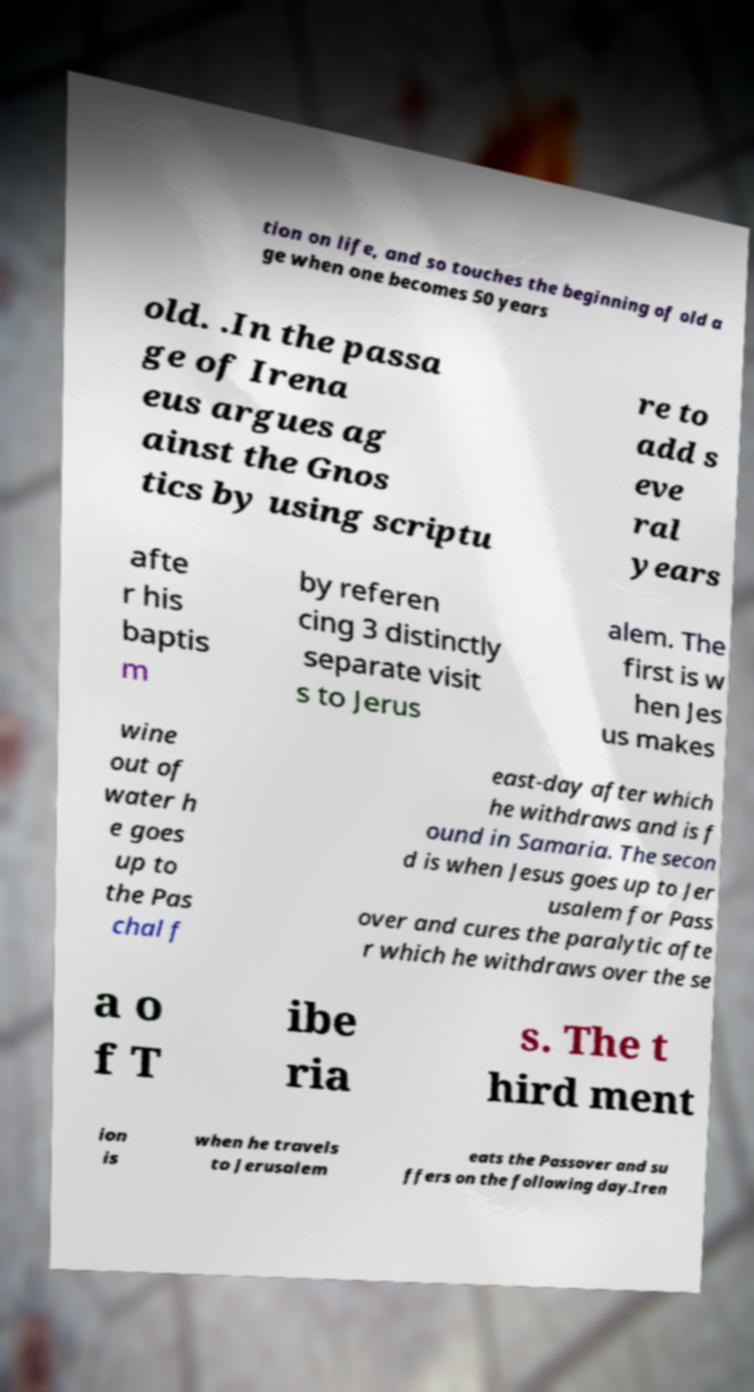Can you accurately transcribe the text from the provided image for me? tion on life, and so touches the beginning of old a ge when one becomes 50 years old. .In the passa ge of Irena eus argues ag ainst the Gnos tics by using scriptu re to add s eve ral years afte r his baptis m by referen cing 3 distinctly separate visit s to Jerus alem. The first is w hen Jes us makes wine out of water h e goes up to the Pas chal f east-day after which he withdraws and is f ound in Samaria. The secon d is when Jesus goes up to Jer usalem for Pass over and cures the paralytic afte r which he withdraws over the se a o f T ibe ria s. The t hird ment ion is when he travels to Jerusalem eats the Passover and su ffers on the following day.Iren 